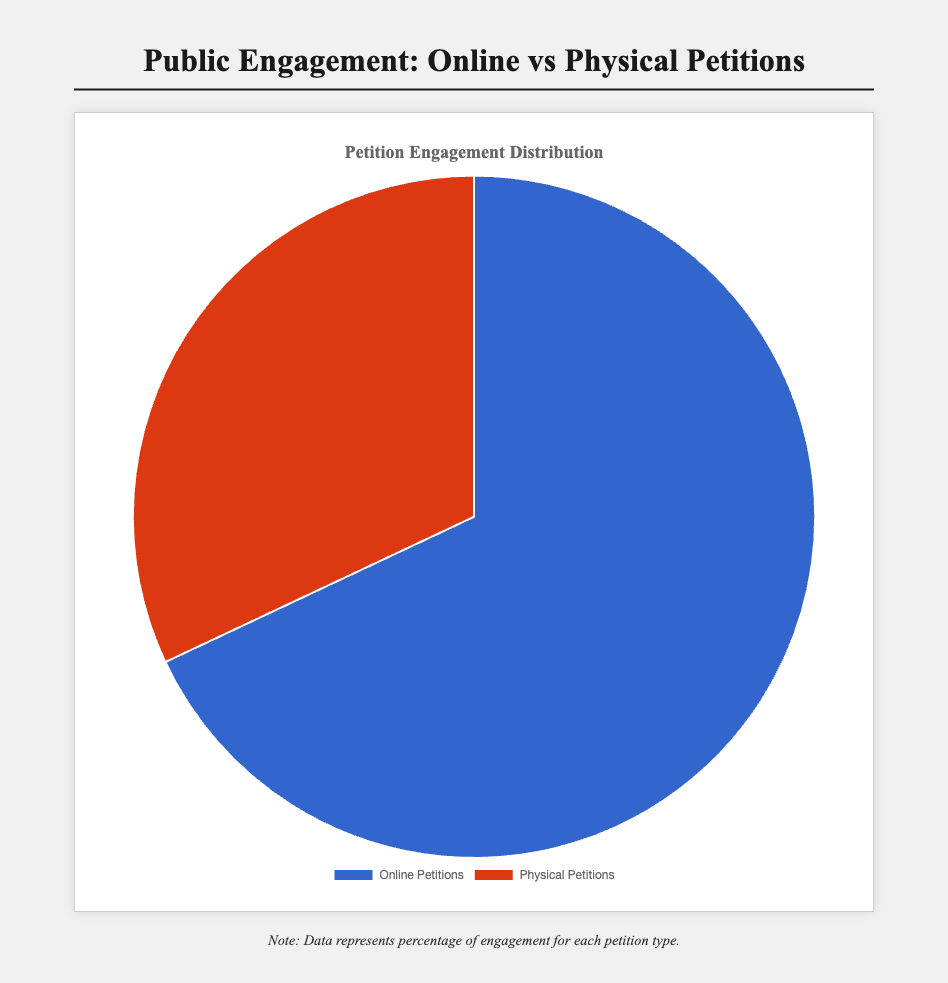What percentage of public engagement is attributed to online petitions? The pie chart shows that the section labeled "Online Petitions" corresponds to a percentage. By directly referring to this label, we can determine the value.
Answer: 68% By how much is the engagement for online petitions greater than physical petitions? The pie chart shows 68% engagement for online petitions and 32% for physical petitions. To find the difference, subtract the smaller percentage from the larger one: 68% - 32%.
Answer: 36% What are the colors used to represent online and physical petitions? The visual indicators on the pie chart use specific colors for each petition type. Observing the legend, "Online Petitions" is represented by blue and "Physical Petitions" is represented by red.
Answer: Online Petitions: Blue, Physical Petitions: Red What is the combined engagement percentage for both online and physical petitions? The percentages indicated are 68% for online petitions and 32% for physical petitions. Adding these together will give the combined engagement: 68% + 32%.
Answer: 100% What portion of the chart is dedicated to physical petitions? By examining the pie chart, the slice labeled "Physical Petitions" corresponds to a specific percentage of the pie. This slice indicates 32%.
Answer: 32% How many times greater is the engagement for online petitions compared to physical petitions? Dividing the engagement percentage of online petitions (68%) by that of physical petitions (32%) gives the multiple by which the online engagement is greater: 68% / 32%.
Answer: Approximately 2.13 times If the engagement percentage for online petitions increased by 10%, what would be the new percentage for physical petitions assuming a constant total of 100%? Adding 10% to the online petitions' engagement percentage results in 68% + 10% = 78%. To balance this under a total of 100%, subtract 10% from the physical petitions' percentage: 32% - 10%.
Answer: Online Petitions: 78%, Physical Petitions: 22% Is the segment representing online petitions larger or smaller than the segment representing physical petitions? By observing the size of the slices on the pie chart, the "Online Petitions" segment occupies a larger portion compared to the "Physical Petitions" segment.
Answer: Larger What would happen to the representation of physical petitions if the engagement percentage dropped to 20%? If physical petitions' engagement drops to 20%, the difference must be added to the online petitions to maintain a 100% total. The new engagement percentage for online petitions would be 100% - 20%.
Answer: Online Petitions: 80%, Physical Petitions: 20% 